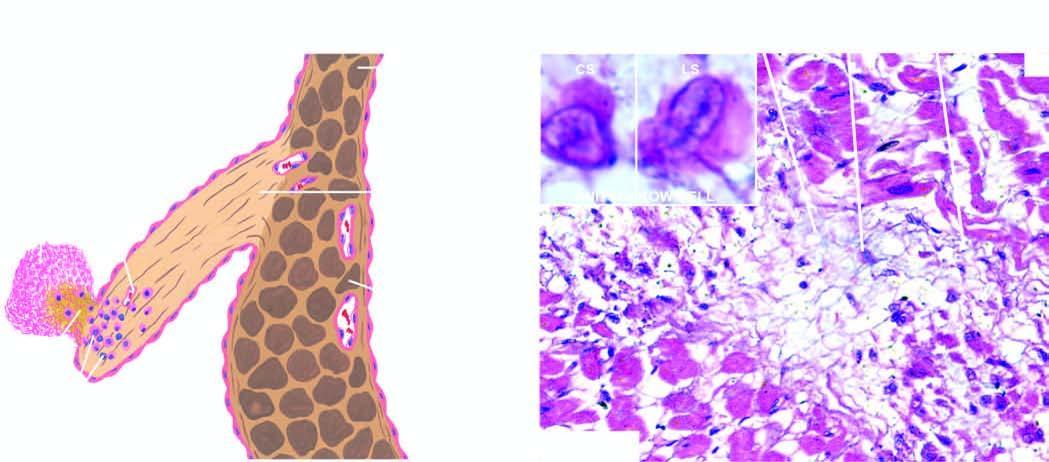what shows an anitschkow cell in cross section and in longitudinal section ls?
Answer the question using a single word or phrase. Inbox 